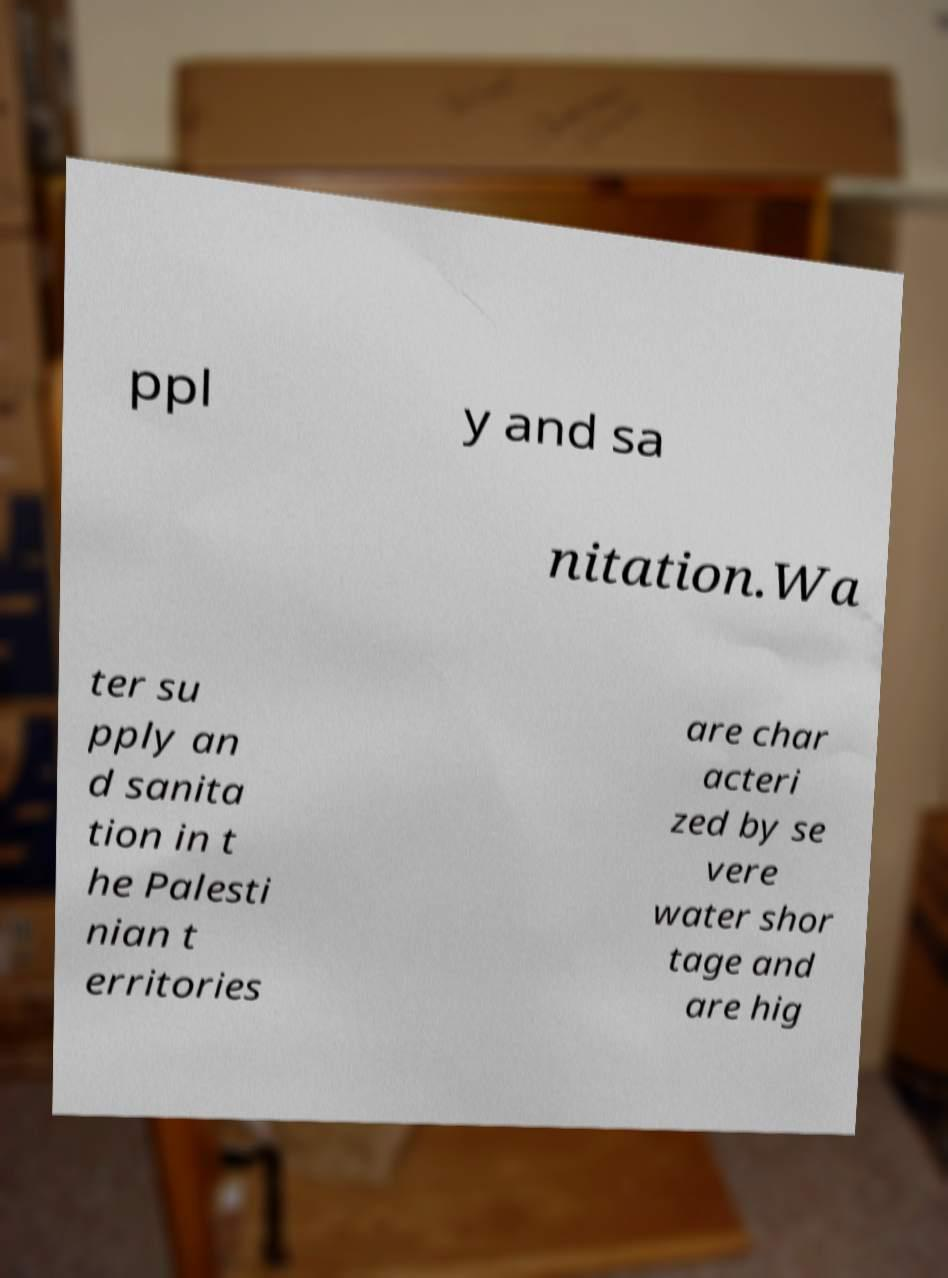There's text embedded in this image that I need extracted. Can you transcribe it verbatim? ppl y and sa nitation.Wa ter su pply an d sanita tion in t he Palesti nian t erritories are char acteri zed by se vere water shor tage and are hig 